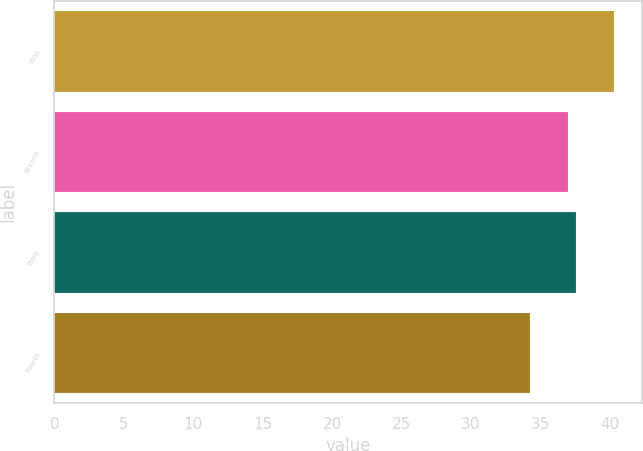<chart> <loc_0><loc_0><loc_500><loc_500><bar_chart><fcel>First<fcel>Second<fcel>Third<fcel>Fourth<nl><fcel>40.28<fcel>36.96<fcel>37.57<fcel>34.22<nl></chart> 